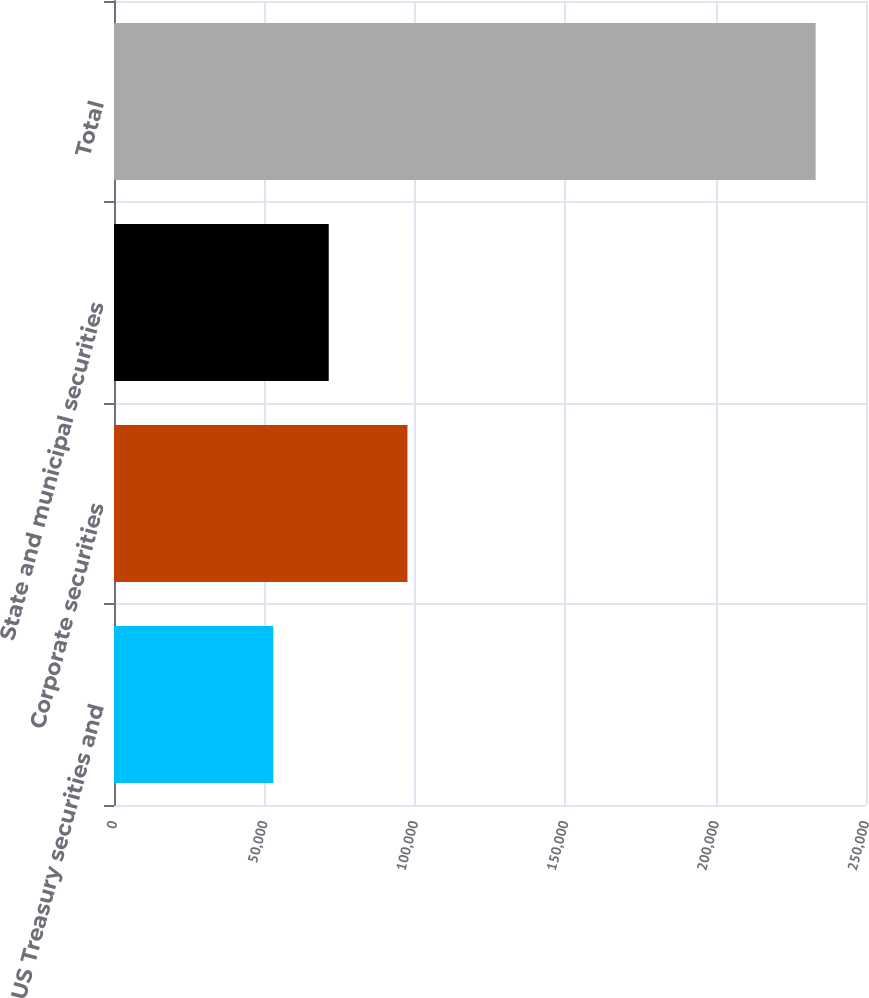Convert chart. <chart><loc_0><loc_0><loc_500><loc_500><bar_chart><fcel>US Treasury securities and<fcel>Corporate securities<fcel>State and municipal securities<fcel>Total<nl><fcel>52958<fcel>97562<fcel>71387<fcel>233257<nl></chart> 